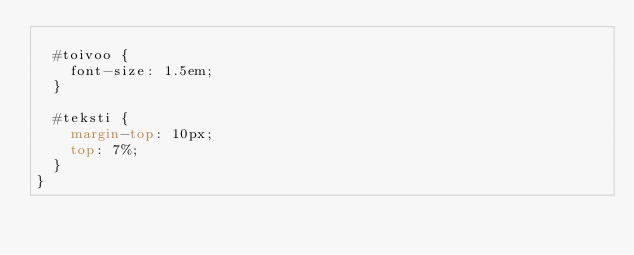Convert code to text. <code><loc_0><loc_0><loc_500><loc_500><_CSS_>
  #toivoo {
    font-size: 1.5em;
  }

  #teksti {
    margin-top: 10px;
    top: 7%;
  }
}
</code> 